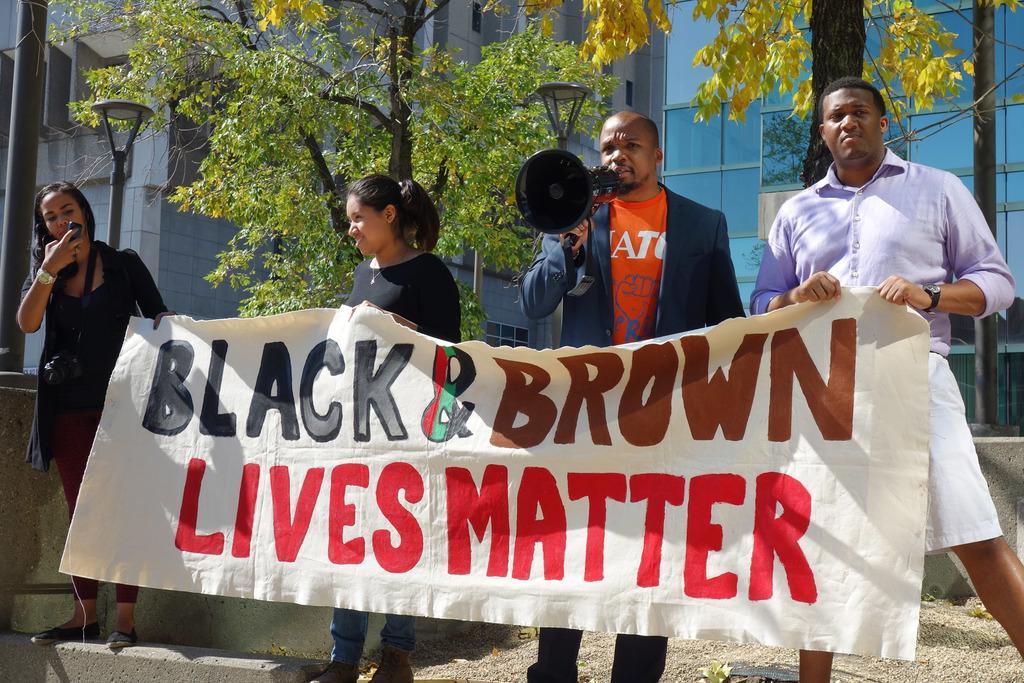Can you describe this image briefly? In the middle of the image four persons are standing and holding a banner and microphone. Behind them there are some trees,poles and buildings. 